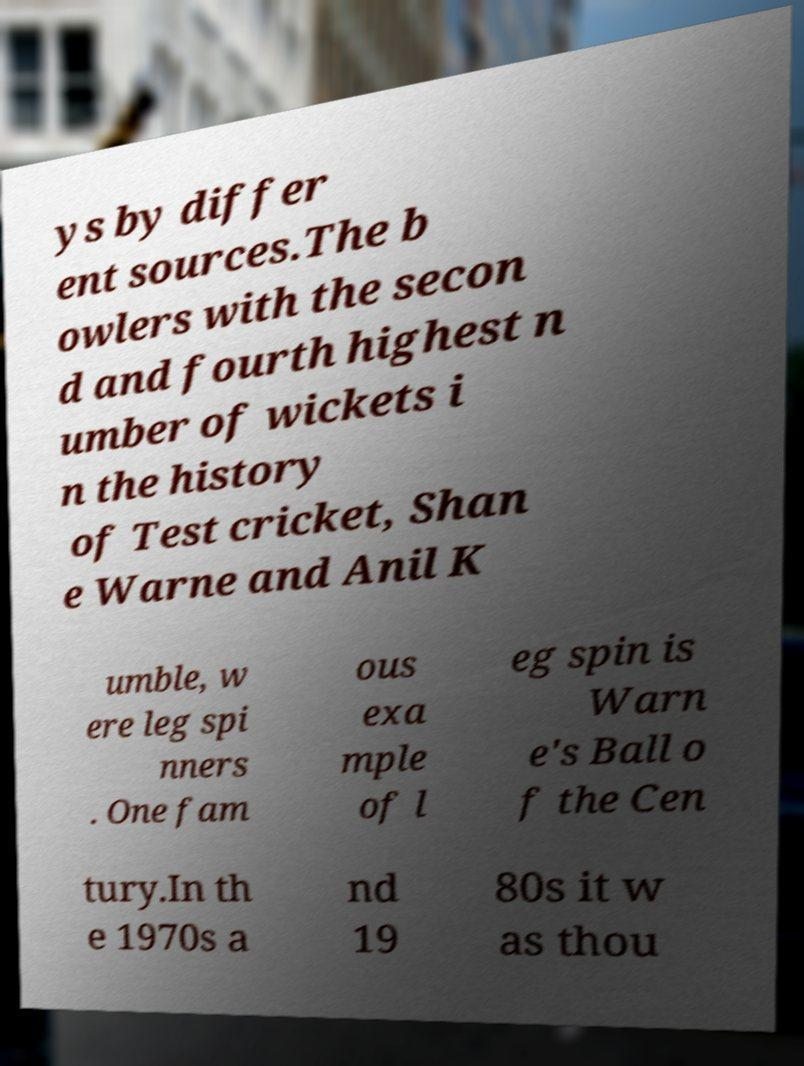Please read and relay the text visible in this image. What does it say? ys by differ ent sources.The b owlers with the secon d and fourth highest n umber of wickets i n the history of Test cricket, Shan e Warne and Anil K umble, w ere leg spi nners . One fam ous exa mple of l eg spin is Warn e's Ball o f the Cen tury.In th e 1970s a nd 19 80s it w as thou 